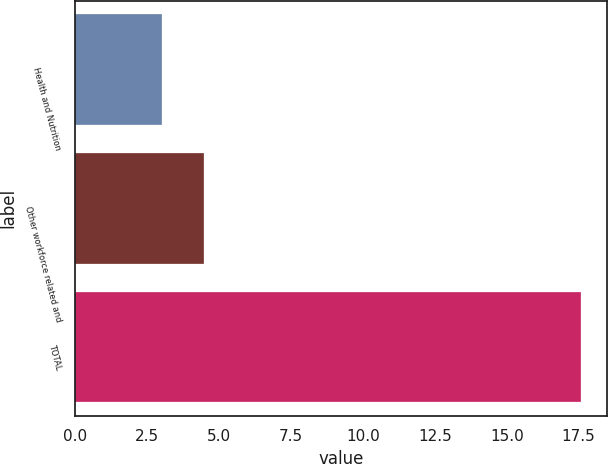<chart> <loc_0><loc_0><loc_500><loc_500><bar_chart><fcel>Health and Nutrition<fcel>Other workforce related and<fcel>TOTAL<nl><fcel>3<fcel>4.46<fcel>17.6<nl></chart> 